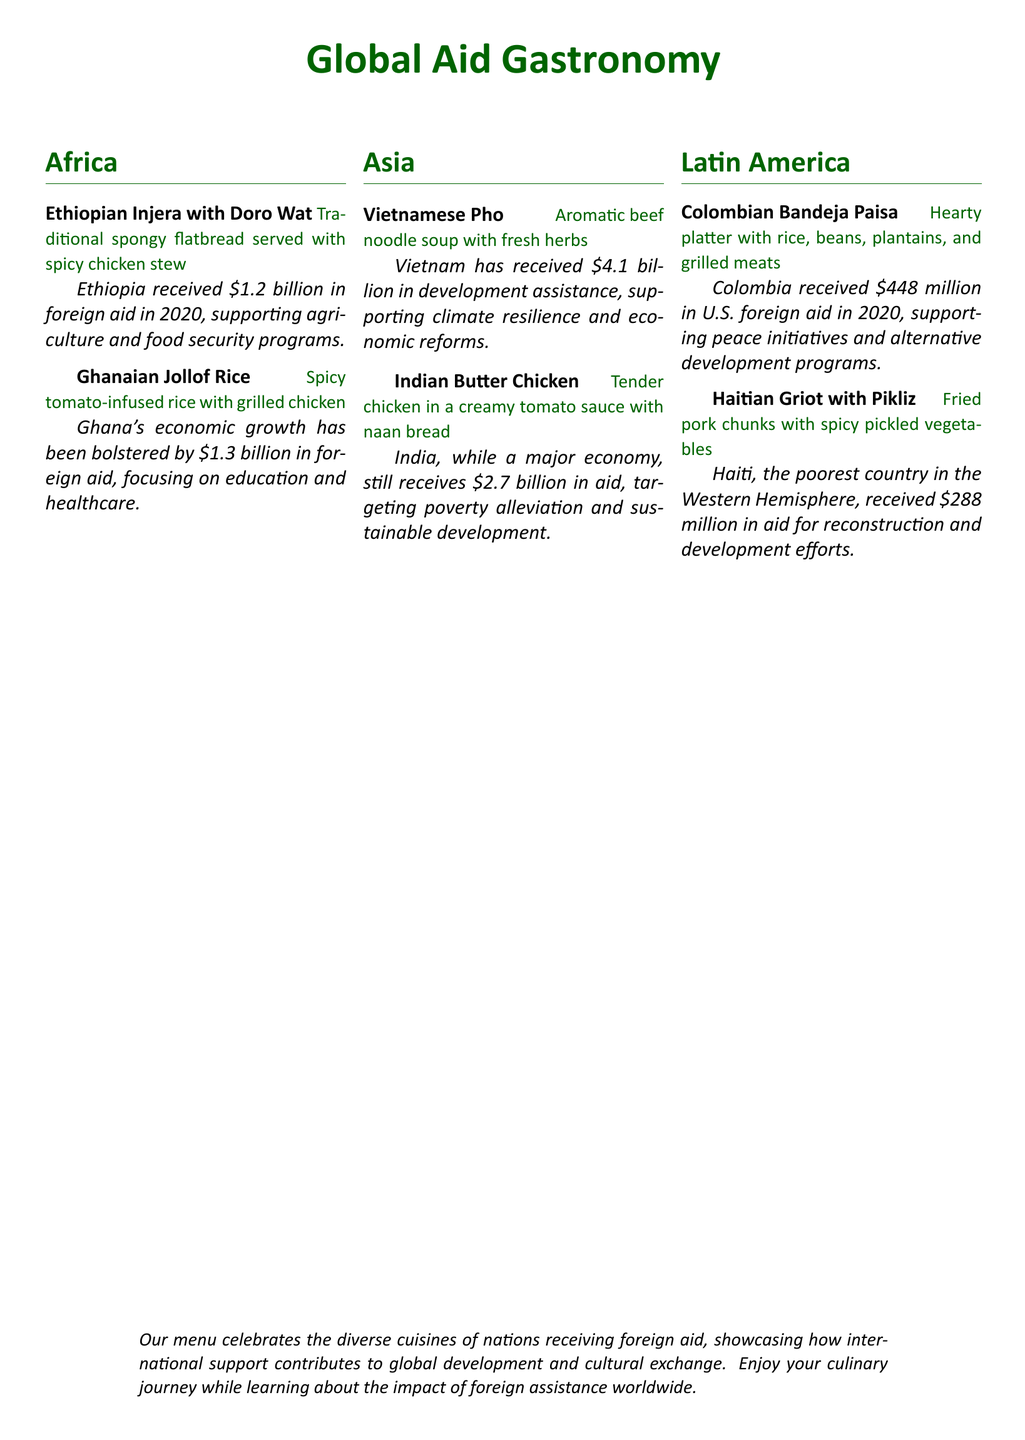What dish is served with spicy chicken stew? The document lists Ethiopian Injera with Doro Wat as the dish served with spicy chicken stew.
Answer: Ethiopian Injera with Doro Wat How much foreign aid did Ghana receive in 2020? The document states that Ghana received $1.3 billion in foreign aid in 2020.
Answer: $1.3 billion What are the components of Colombian Bandeja Paisa? The description includes rice, beans, plantains, and grilled meats as the components of Colombian Bandeja Paisa.
Answer: Rice, beans, plantains, and grilled meats What is the total amount of aid Vietnam received? The menu indicates Vietnam has received $4.1 billion in development assistance.
Answer: $4.1 billion Which dish is associated with Haiti? The menu specifies Haitian Griot with Pikliz as the dish associated with Haiti.
Answer: Haitian Griot with Pikliz How does foreign aid impact Ethiopia according to the menu? The document mentions that foreign aid supports agriculture and food security programs in Ethiopia.
Answer: Agriculture and food security programs What cuisine is recognized from the Latin America section? The Latin America section includes Colombian cuisine represented by Bandeja Paisa.
Answer: Colombian cuisine What type of assistance does India receive from foreign aid? The document states that India targets poverty alleviation and sustainable development through foreign aid.
Answer: Poverty alleviation and sustainable development 